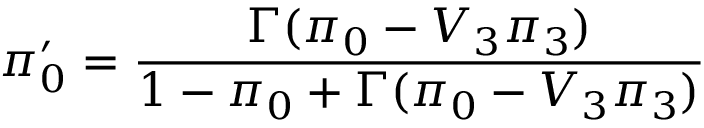Convert formula to latex. <formula><loc_0><loc_0><loc_500><loc_500>\pi _ { 0 } ^ { \prime } = \frac { \Gamma ( \pi _ { 0 } - V _ { 3 } \pi _ { 3 } ) } { 1 - \pi _ { 0 } + \Gamma ( \pi _ { 0 } - V _ { 3 } \pi _ { 3 } ) }</formula> 